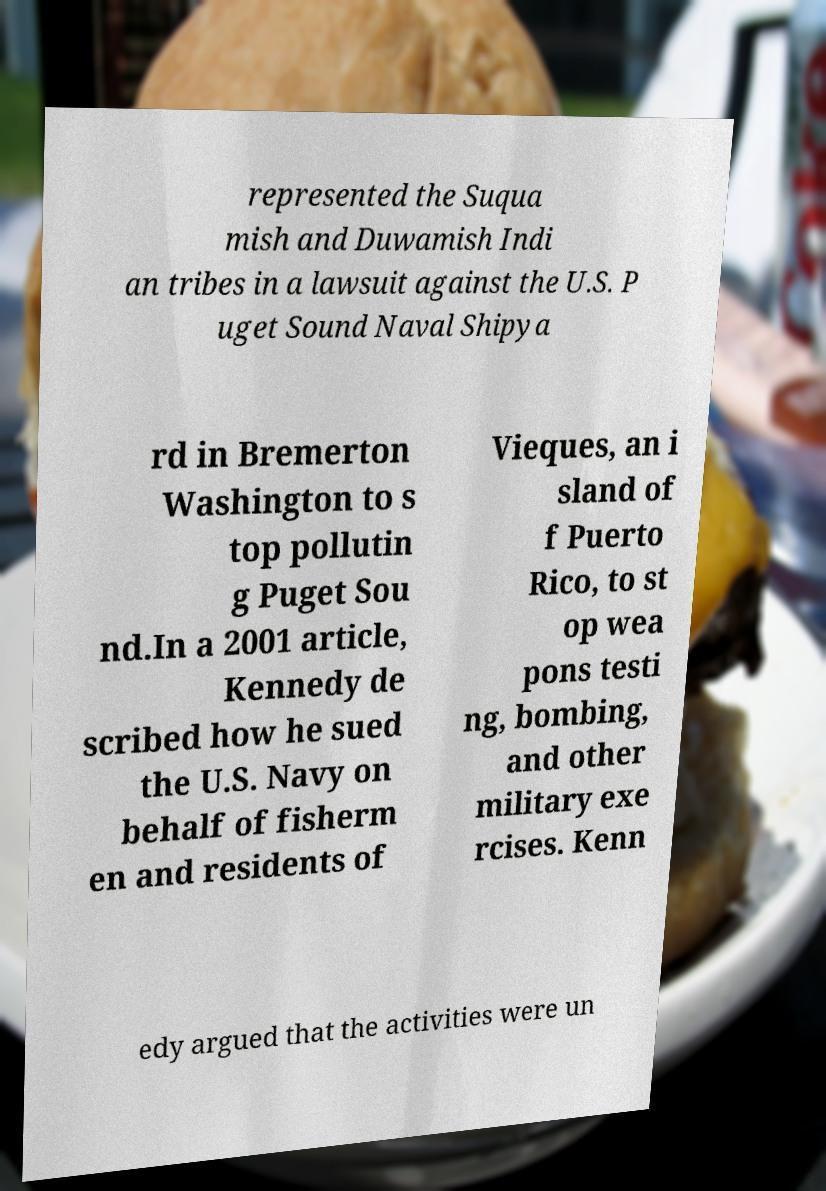Can you accurately transcribe the text from the provided image for me? represented the Suqua mish and Duwamish Indi an tribes in a lawsuit against the U.S. P uget Sound Naval Shipya rd in Bremerton Washington to s top pollutin g Puget Sou nd.In a 2001 article, Kennedy de scribed how he sued the U.S. Navy on behalf of fisherm en and residents of Vieques, an i sland of f Puerto Rico, to st op wea pons testi ng, bombing, and other military exe rcises. Kenn edy argued that the activities were un 